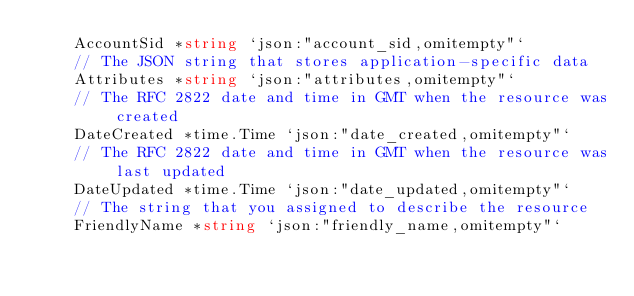Convert code to text. <code><loc_0><loc_0><loc_500><loc_500><_Go_>	AccountSid *string `json:"account_sid,omitempty"`
	// The JSON string that stores application-specific data
	Attributes *string `json:"attributes,omitempty"`
	// The RFC 2822 date and time in GMT when the resource was created
	DateCreated *time.Time `json:"date_created,omitempty"`
	// The RFC 2822 date and time in GMT when the resource was last updated
	DateUpdated *time.Time `json:"date_updated,omitempty"`
	// The string that you assigned to describe the resource
	FriendlyName *string `json:"friendly_name,omitempty"`</code> 